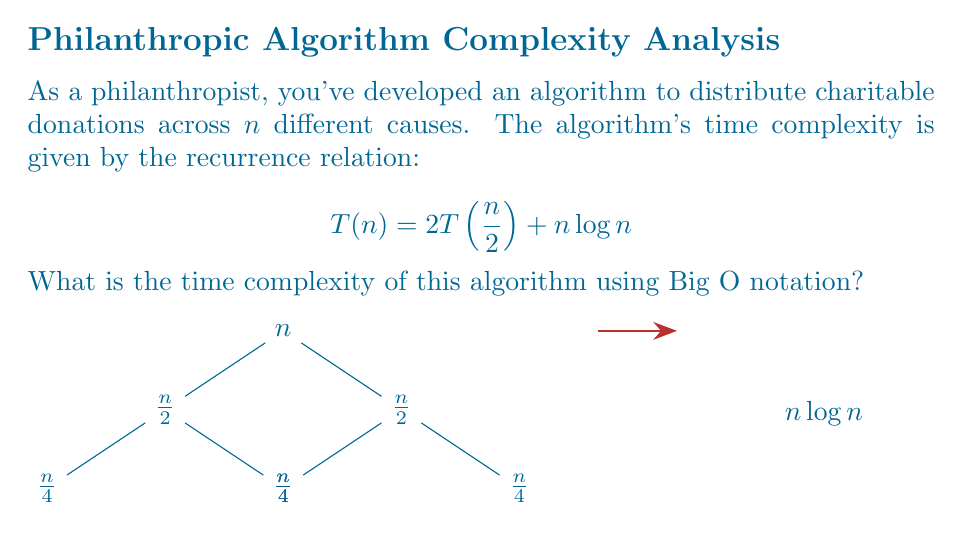Solve this math problem. To solve this recurrence relation, we'll use the Master Theorem. The general form of the Master Theorem is:

$$T(n) = aT(\frac{n}{b}) + f(n)$$

In our case:
- $a = 2$ (number of subproblems)
- $b = 2$ (factor by which the problem size is reduced)
- $f(n) = n\log n$ (cost of dividing and combining)

We need to compare $n^{\log_b a}$ with $f(n)$:

1) First, calculate $\log_b a$:
   $$\log_2 2 = 1$$

2) So, $n^{\log_b a} = n^1 = n$

3) Compare $n$ with $n\log n$:
   $$n < n\log n$$

This falls under case 3 of the Master Theorem, where $f(n) = \Omega(n^{\log_b a + \epsilon})$ for some $\epsilon > 0$. 
In this case, $\epsilon$ can be any positive value less than 1.

4) We also need to check the regularity condition:
   $$af(\frac{n}{b}) \leq cf(n)$$ for some $c < 1$ and sufficiently large $n$
   
   $$2(\frac{n}{2}\log\frac{n}{2}) \leq cn\log n$$
   $$n\log\frac{n}{2} \leq cn\log n$$
   $$\log n - 1 \leq c\log n$$
   
   This condition is satisfied for $c$ close to 1 and large $n$.

5) Therefore, according to the Master Theorem case 3:
   $$T(n) = \Theta(f(n)) = \Theta(n\log n)$$

Thus, the time complexity of the algorithm is $O(n\log n)$.
Answer: $O(n\log n)$ 